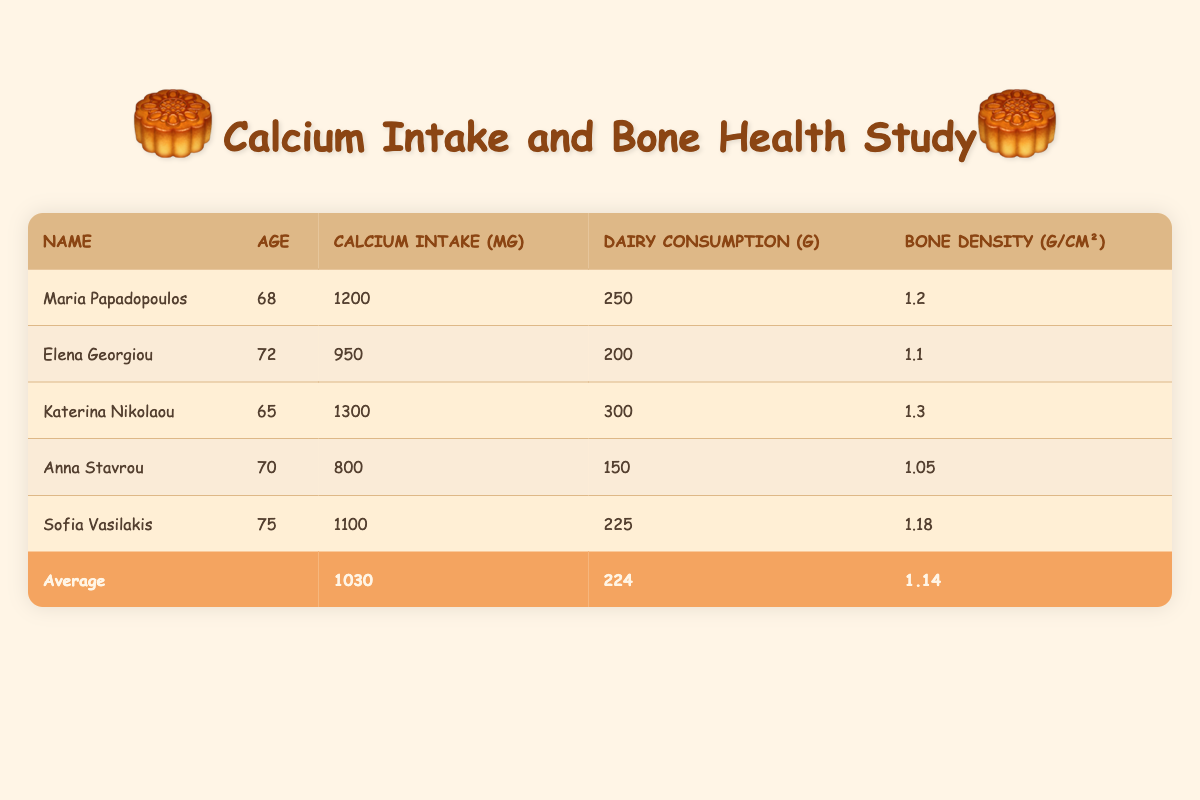What is the calcium intake of Katerina Nikolaou? From the table, we can find Katerina Nikolaou listed. Under the "Calcium Intake (mg)" column, her intake is recorded as 1300 mg.
Answer: 1300 mg What is the average dairy consumption among all participants? To calculate the average dairy consumption, we add up the total dairy consumption for all participants: (250 + 200 + 300 + 150 + 225) = 1125 g. Then, we divide by the number of participants, which is 5: 1125 / 5 = 225 g.
Answer: 225 g Is Elena Georgiou's bone density greater than the average bone density? We find Elena Georgiou's bone density in the table, which is 1.1 g/cm². The average bone density listed is 1.14 g/cm². Since 1.1 is less than 1.14, the answer is "no."
Answer: No What is the sum of calcium intake for all participants? We sum the calcium intake values for each participant: 1200 + 950 + 1300 + 800 + 1100 = 4350 mg. The sum of these values gives us the total calcium intake.
Answer: 4350 mg How many participants have a bone density above 1.2 g/cm²? In the table, we check the bone density for each participant: Maria (1.2), Elena (1.1), Katerina (1.3), Anna (1.05), and Sofia (1.18). Only Katerina has a bone density above 1.2 g/cm², so the count is 1.
Answer: 1 What is the average calcium intake of the participants? The average calcium intake is already provided in the summary at the bottom of the table. It states the average calcium intake is 1030 mg.
Answer: 1030 mg Is Anna Stavrou the oldest participant in the study? Anna Stavrou's age is listed as 70. The oldest participant is Sofia Vasilakis, who is 75 years old, so the answer is "no."
Answer: No What is the difference in dairy consumption between Katerina Nikolaou and Anna Stavrou? Katerina's dairy consumption is 300 g, and Anna's is 150 g. The difference is 300 - 150 = 150 g.
Answer: 150 g How many participants have a calcium intake less than 1000 mg? Reviewing the table, we see the following calcium intakes: Maria (1200 mg), Elena (950 mg), Katerina (1300 mg), Anna (800 mg), Sofia (1100 mg). Only Elena and Anna have intakes less than 1000 mg, totaling 2 participants.
Answer: 2 